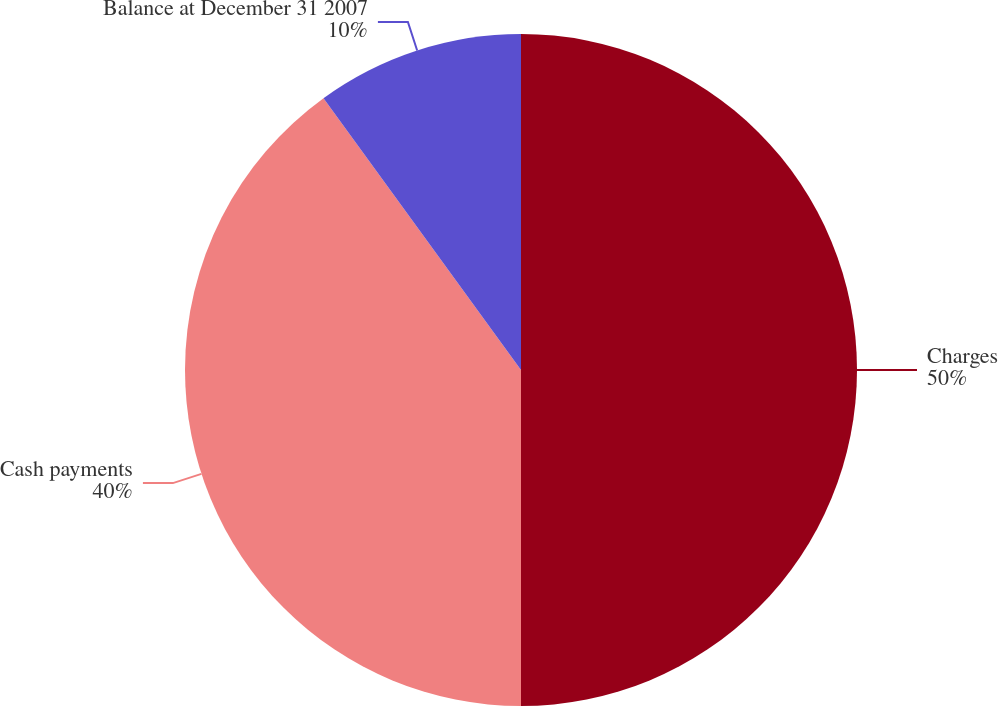Convert chart. <chart><loc_0><loc_0><loc_500><loc_500><pie_chart><fcel>Charges<fcel>Cash payments<fcel>Balance at December 31 2007<nl><fcel>50.0%<fcel>40.0%<fcel>10.0%<nl></chart> 